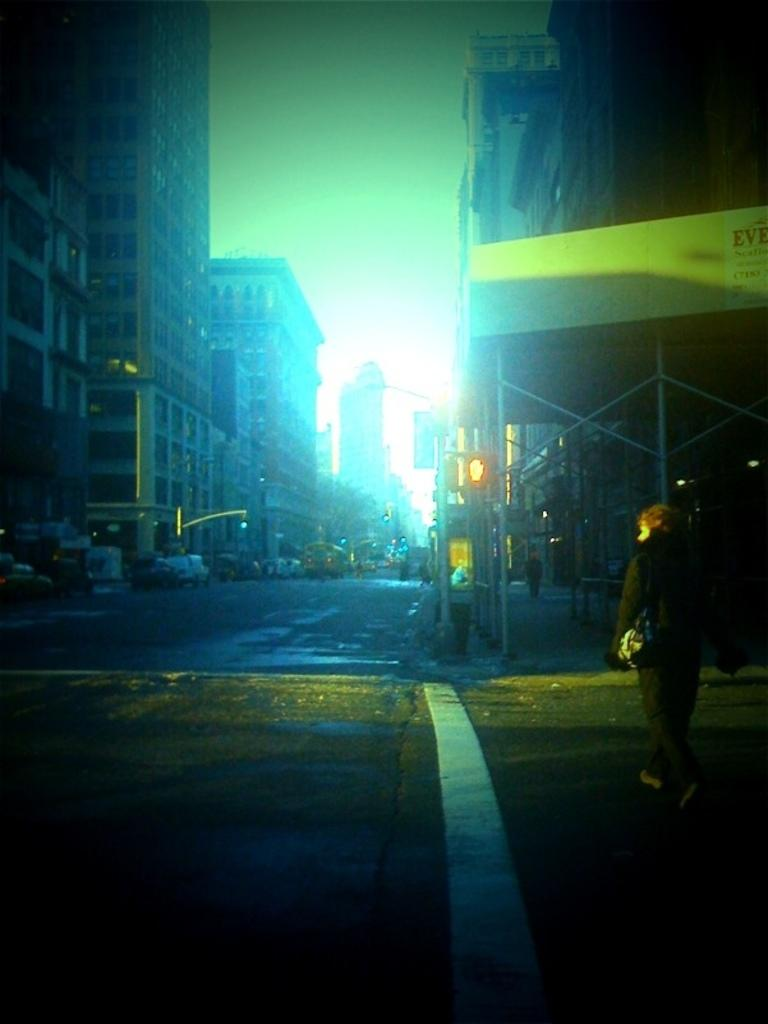What is the person in the image doing? There is a person standing on the road in the image. What else can be seen on the road? There are cars parked on the road. What can be seen in the distance behind the person? There are buildings visible in the background. What color is the shirt the person is wearing in the image? The provided facts do not mention the color of the person's shirt, so we cannot determine the color from the image. 